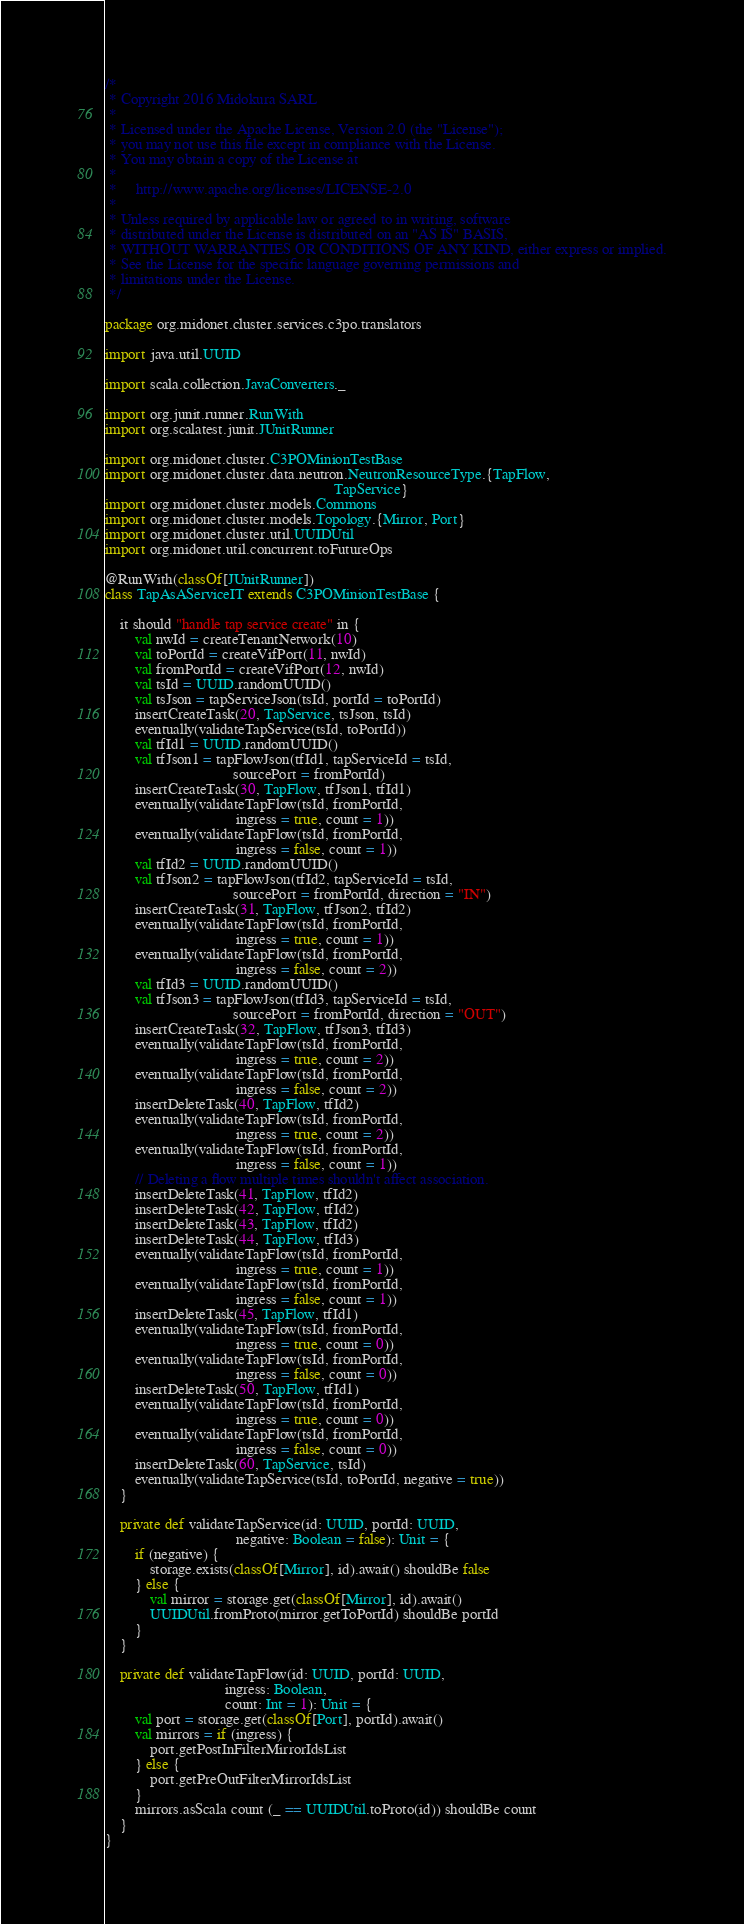Convert code to text. <code><loc_0><loc_0><loc_500><loc_500><_Scala_>/*
 * Copyright 2016 Midokura SARL
 *
 * Licensed under the Apache License, Version 2.0 (the "License");
 * you may not use this file except in compliance with the License.
 * You may obtain a copy of the License at
 *
 *     http://www.apache.org/licenses/LICENSE-2.0
 *
 * Unless required by applicable law or agreed to in writing, software
 * distributed under the License is distributed on an "AS IS" BASIS,
 * WITHOUT WARRANTIES OR CONDITIONS OF ANY KIND, either express or implied.
 * See the License for the specific language governing permissions and
 * limitations under the License.
 */

package org.midonet.cluster.services.c3po.translators

import java.util.UUID

import scala.collection.JavaConverters._

import org.junit.runner.RunWith
import org.scalatest.junit.JUnitRunner

import org.midonet.cluster.C3POMinionTestBase
import org.midonet.cluster.data.neutron.NeutronResourceType.{TapFlow,
                                                             TapService}
import org.midonet.cluster.models.Commons
import org.midonet.cluster.models.Topology.{Mirror, Port}
import org.midonet.cluster.util.UUIDUtil
import org.midonet.util.concurrent.toFutureOps

@RunWith(classOf[JUnitRunner])
class TapAsAServiceIT extends C3POMinionTestBase {

    it should "handle tap service create" in {
        val nwId = createTenantNetwork(10)
        val toPortId = createVifPort(11, nwId)
        val fromPortId = createVifPort(12, nwId)
        val tsId = UUID.randomUUID()
        val tsJson = tapServiceJson(tsId, portId = toPortId)
        insertCreateTask(20, TapService, tsJson, tsId)
        eventually(validateTapService(tsId, toPortId))
        val tfId1 = UUID.randomUUID()
        val tfJson1 = tapFlowJson(tfId1, tapServiceId = tsId,
                                  sourcePort = fromPortId)
        insertCreateTask(30, TapFlow, tfJson1, tfId1)
        eventually(validateTapFlow(tsId, fromPortId,
                                   ingress = true, count = 1))
        eventually(validateTapFlow(tsId, fromPortId,
                                   ingress = false, count = 1))
        val tfId2 = UUID.randomUUID()
        val tfJson2 = tapFlowJson(tfId2, tapServiceId = tsId,
                                  sourcePort = fromPortId, direction = "IN")
        insertCreateTask(31, TapFlow, tfJson2, tfId2)
        eventually(validateTapFlow(tsId, fromPortId,
                                   ingress = true, count = 1))
        eventually(validateTapFlow(tsId, fromPortId,
                                   ingress = false, count = 2))
        val tfId3 = UUID.randomUUID()
        val tfJson3 = tapFlowJson(tfId3, tapServiceId = tsId,
                                  sourcePort = fromPortId, direction = "OUT")
        insertCreateTask(32, TapFlow, tfJson3, tfId3)
        eventually(validateTapFlow(tsId, fromPortId,
                                   ingress = true, count = 2))
        eventually(validateTapFlow(tsId, fromPortId,
                                   ingress = false, count = 2))
        insertDeleteTask(40, TapFlow, tfId2)
        eventually(validateTapFlow(tsId, fromPortId,
                                   ingress = true, count = 2))
        eventually(validateTapFlow(tsId, fromPortId,
                                   ingress = false, count = 1))
        // Deleting a flow multiple times shouldn't affect association.
        insertDeleteTask(41, TapFlow, tfId2)
        insertDeleteTask(42, TapFlow, tfId2)
        insertDeleteTask(43, TapFlow, tfId2)
        insertDeleteTask(44, TapFlow, tfId3)
        eventually(validateTapFlow(tsId, fromPortId,
                                   ingress = true, count = 1))
        eventually(validateTapFlow(tsId, fromPortId,
                                   ingress = false, count = 1))
        insertDeleteTask(45, TapFlow, tfId1)
        eventually(validateTapFlow(tsId, fromPortId,
                                   ingress = true, count = 0))
        eventually(validateTapFlow(tsId, fromPortId,
                                   ingress = false, count = 0))
        insertDeleteTask(50, TapFlow, tfId1)
        eventually(validateTapFlow(tsId, fromPortId,
                                   ingress = true, count = 0))
        eventually(validateTapFlow(tsId, fromPortId,
                                   ingress = false, count = 0))
        insertDeleteTask(60, TapService, tsId)
        eventually(validateTapService(tsId, toPortId, negative = true))
    }

    private def validateTapService(id: UUID, portId: UUID,
                                   negative: Boolean = false): Unit = {
        if (negative) {
            storage.exists(classOf[Mirror], id).await() shouldBe false
        } else {
            val mirror = storage.get(classOf[Mirror], id).await()
            UUIDUtil.fromProto(mirror.getToPortId) shouldBe portId
        }
    }

    private def validateTapFlow(id: UUID, portId: UUID,
                                ingress: Boolean,
                                count: Int = 1): Unit = {
        val port = storage.get(classOf[Port], portId).await()
        val mirrors = if (ingress) {
            port.getPostInFilterMirrorIdsList
        } else {
            port.getPreOutFilterMirrorIdsList
        }
        mirrors.asScala count (_ == UUIDUtil.toProto(id)) shouldBe count
    }
}
</code> 